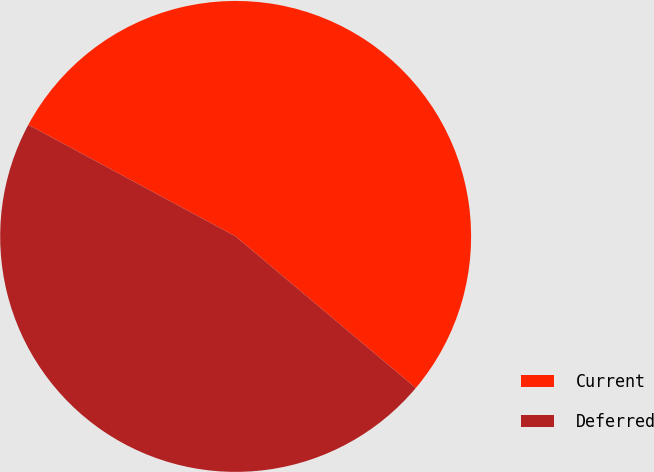Convert chart to OTSL. <chart><loc_0><loc_0><loc_500><loc_500><pie_chart><fcel>Current<fcel>Deferred<nl><fcel>53.27%<fcel>46.73%<nl></chart> 